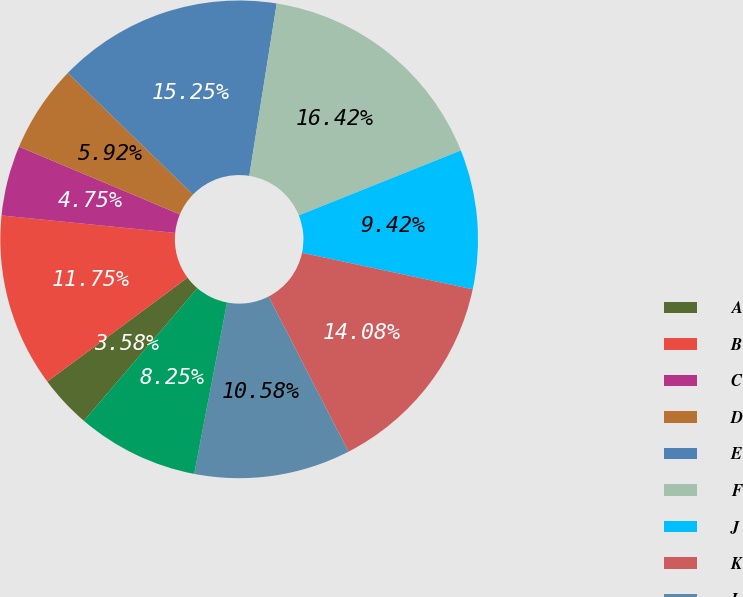<chart> <loc_0><loc_0><loc_500><loc_500><pie_chart><fcel>A<fcel>B<fcel>C<fcel>D<fcel>E<fcel>F<fcel>J<fcel>K<fcel>L<fcel>M<nl><fcel>3.58%<fcel>11.75%<fcel>4.75%<fcel>5.92%<fcel>15.25%<fcel>16.42%<fcel>9.42%<fcel>14.08%<fcel>10.58%<fcel>8.25%<nl></chart> 